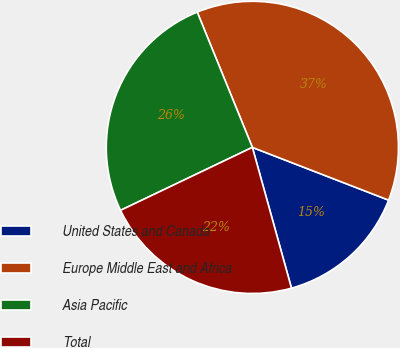<chart> <loc_0><loc_0><loc_500><loc_500><pie_chart><fcel>United States and Canada<fcel>Europe Middle East and Africa<fcel>Asia Pacific<fcel>Total<nl><fcel>14.81%<fcel>37.04%<fcel>25.93%<fcel>22.22%<nl></chart> 